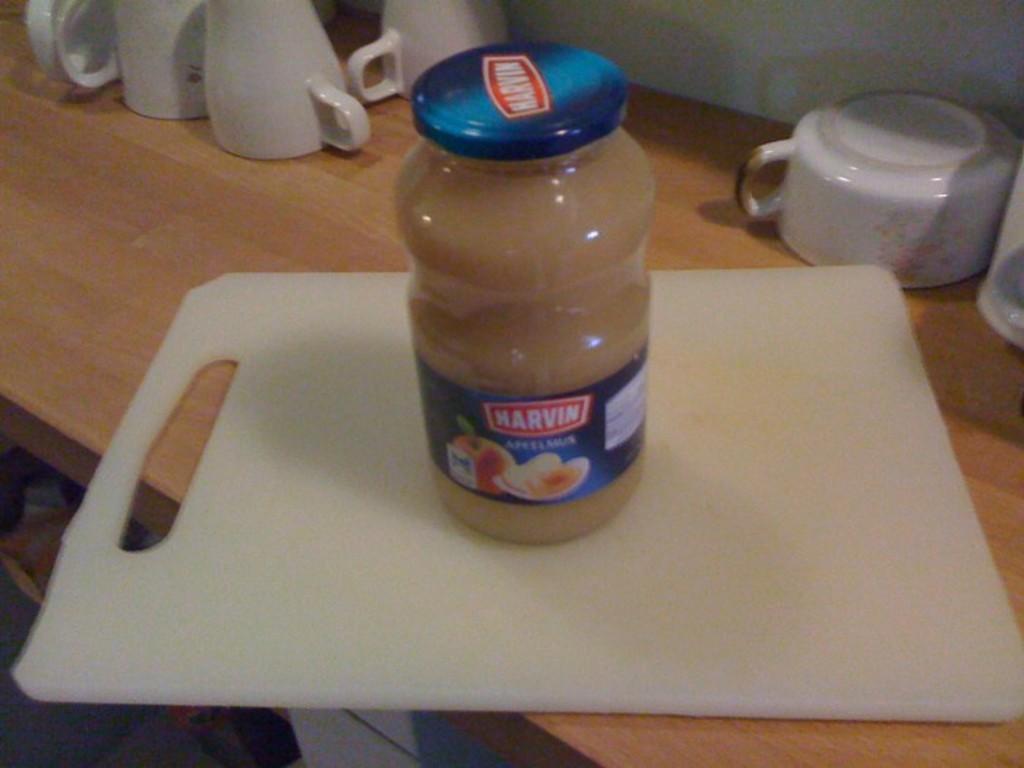What is the brand of this condiment?
Provide a short and direct response. Harvin. 